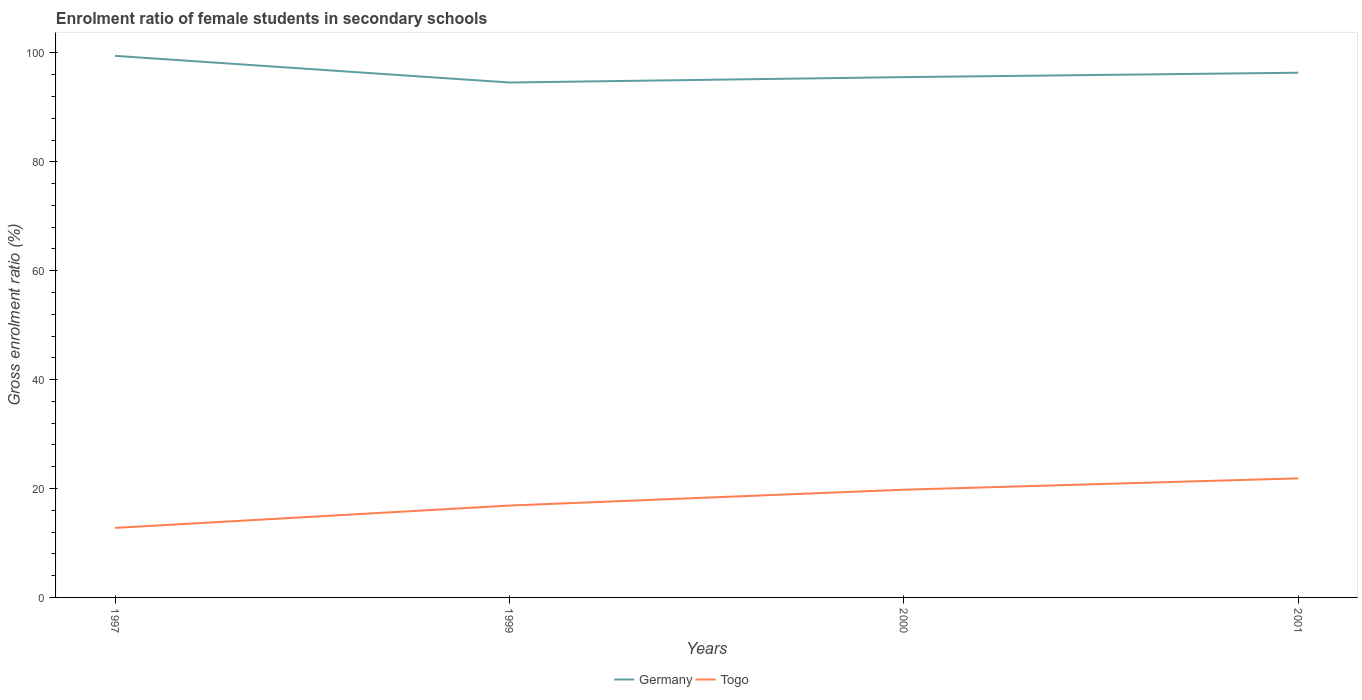Does the line corresponding to Germany intersect with the line corresponding to Togo?
Make the answer very short. No. Is the number of lines equal to the number of legend labels?
Keep it short and to the point. Yes. Across all years, what is the maximum enrolment ratio of female students in secondary schools in Germany?
Ensure brevity in your answer.  94.56. In which year was the enrolment ratio of female students in secondary schools in Togo maximum?
Ensure brevity in your answer.  1997. What is the total enrolment ratio of female students in secondary schools in Togo in the graph?
Your answer should be very brief. -9.1. What is the difference between the highest and the second highest enrolment ratio of female students in secondary schools in Togo?
Your response must be concise. 9.1. What is the difference between the highest and the lowest enrolment ratio of female students in secondary schools in Germany?
Provide a succinct answer. 1. How many lines are there?
Keep it short and to the point. 2. How many years are there in the graph?
Give a very brief answer. 4. Does the graph contain grids?
Ensure brevity in your answer.  No. How many legend labels are there?
Give a very brief answer. 2. How are the legend labels stacked?
Offer a very short reply. Horizontal. What is the title of the graph?
Provide a succinct answer. Enrolment ratio of female students in secondary schools. What is the label or title of the X-axis?
Your answer should be compact. Years. What is the Gross enrolment ratio (%) of Germany in 1997?
Offer a very short reply. 99.46. What is the Gross enrolment ratio (%) of Togo in 1997?
Keep it short and to the point. 12.77. What is the Gross enrolment ratio (%) in Germany in 1999?
Your answer should be very brief. 94.56. What is the Gross enrolment ratio (%) in Togo in 1999?
Give a very brief answer. 16.87. What is the Gross enrolment ratio (%) in Germany in 2000?
Your answer should be compact. 95.55. What is the Gross enrolment ratio (%) in Togo in 2000?
Offer a very short reply. 19.78. What is the Gross enrolment ratio (%) in Germany in 2001?
Offer a very short reply. 96.36. What is the Gross enrolment ratio (%) of Togo in 2001?
Offer a terse response. 21.87. Across all years, what is the maximum Gross enrolment ratio (%) in Germany?
Offer a very short reply. 99.46. Across all years, what is the maximum Gross enrolment ratio (%) of Togo?
Give a very brief answer. 21.87. Across all years, what is the minimum Gross enrolment ratio (%) of Germany?
Offer a terse response. 94.56. Across all years, what is the minimum Gross enrolment ratio (%) of Togo?
Make the answer very short. 12.77. What is the total Gross enrolment ratio (%) of Germany in the graph?
Your response must be concise. 385.92. What is the total Gross enrolment ratio (%) of Togo in the graph?
Give a very brief answer. 71.29. What is the difference between the Gross enrolment ratio (%) of Germany in 1997 and that in 1999?
Provide a short and direct response. 4.9. What is the difference between the Gross enrolment ratio (%) in Togo in 1997 and that in 1999?
Give a very brief answer. -4.1. What is the difference between the Gross enrolment ratio (%) of Germany in 1997 and that in 2000?
Provide a succinct answer. 3.91. What is the difference between the Gross enrolment ratio (%) in Togo in 1997 and that in 2000?
Your response must be concise. -7.01. What is the difference between the Gross enrolment ratio (%) in Germany in 1997 and that in 2001?
Make the answer very short. 3.1. What is the difference between the Gross enrolment ratio (%) of Togo in 1997 and that in 2001?
Ensure brevity in your answer.  -9.1. What is the difference between the Gross enrolment ratio (%) in Germany in 1999 and that in 2000?
Provide a succinct answer. -0.99. What is the difference between the Gross enrolment ratio (%) in Togo in 1999 and that in 2000?
Give a very brief answer. -2.91. What is the difference between the Gross enrolment ratio (%) in Germany in 1999 and that in 2001?
Your answer should be very brief. -1.8. What is the difference between the Gross enrolment ratio (%) of Togo in 1999 and that in 2001?
Provide a short and direct response. -5. What is the difference between the Gross enrolment ratio (%) of Germany in 2000 and that in 2001?
Keep it short and to the point. -0.81. What is the difference between the Gross enrolment ratio (%) of Togo in 2000 and that in 2001?
Offer a very short reply. -2.09. What is the difference between the Gross enrolment ratio (%) of Germany in 1997 and the Gross enrolment ratio (%) of Togo in 1999?
Make the answer very short. 82.58. What is the difference between the Gross enrolment ratio (%) of Germany in 1997 and the Gross enrolment ratio (%) of Togo in 2000?
Your response must be concise. 79.67. What is the difference between the Gross enrolment ratio (%) in Germany in 1997 and the Gross enrolment ratio (%) in Togo in 2001?
Your answer should be very brief. 77.59. What is the difference between the Gross enrolment ratio (%) in Germany in 1999 and the Gross enrolment ratio (%) in Togo in 2000?
Ensure brevity in your answer.  74.78. What is the difference between the Gross enrolment ratio (%) in Germany in 1999 and the Gross enrolment ratio (%) in Togo in 2001?
Offer a very short reply. 72.69. What is the difference between the Gross enrolment ratio (%) of Germany in 2000 and the Gross enrolment ratio (%) of Togo in 2001?
Your response must be concise. 73.68. What is the average Gross enrolment ratio (%) in Germany per year?
Keep it short and to the point. 96.48. What is the average Gross enrolment ratio (%) of Togo per year?
Keep it short and to the point. 17.82. In the year 1997, what is the difference between the Gross enrolment ratio (%) of Germany and Gross enrolment ratio (%) of Togo?
Offer a terse response. 86.69. In the year 1999, what is the difference between the Gross enrolment ratio (%) of Germany and Gross enrolment ratio (%) of Togo?
Your answer should be very brief. 77.69. In the year 2000, what is the difference between the Gross enrolment ratio (%) of Germany and Gross enrolment ratio (%) of Togo?
Offer a terse response. 75.77. In the year 2001, what is the difference between the Gross enrolment ratio (%) of Germany and Gross enrolment ratio (%) of Togo?
Make the answer very short. 74.49. What is the ratio of the Gross enrolment ratio (%) in Germany in 1997 to that in 1999?
Your response must be concise. 1.05. What is the ratio of the Gross enrolment ratio (%) of Togo in 1997 to that in 1999?
Provide a short and direct response. 0.76. What is the ratio of the Gross enrolment ratio (%) in Germany in 1997 to that in 2000?
Your answer should be very brief. 1.04. What is the ratio of the Gross enrolment ratio (%) of Togo in 1997 to that in 2000?
Give a very brief answer. 0.65. What is the ratio of the Gross enrolment ratio (%) in Germany in 1997 to that in 2001?
Keep it short and to the point. 1.03. What is the ratio of the Gross enrolment ratio (%) of Togo in 1997 to that in 2001?
Give a very brief answer. 0.58. What is the ratio of the Gross enrolment ratio (%) of Togo in 1999 to that in 2000?
Keep it short and to the point. 0.85. What is the ratio of the Gross enrolment ratio (%) of Germany in 1999 to that in 2001?
Ensure brevity in your answer.  0.98. What is the ratio of the Gross enrolment ratio (%) of Togo in 1999 to that in 2001?
Ensure brevity in your answer.  0.77. What is the ratio of the Gross enrolment ratio (%) of Togo in 2000 to that in 2001?
Ensure brevity in your answer.  0.9. What is the difference between the highest and the second highest Gross enrolment ratio (%) of Germany?
Ensure brevity in your answer.  3.1. What is the difference between the highest and the second highest Gross enrolment ratio (%) in Togo?
Offer a very short reply. 2.09. What is the difference between the highest and the lowest Gross enrolment ratio (%) in Germany?
Make the answer very short. 4.9. What is the difference between the highest and the lowest Gross enrolment ratio (%) of Togo?
Ensure brevity in your answer.  9.1. 